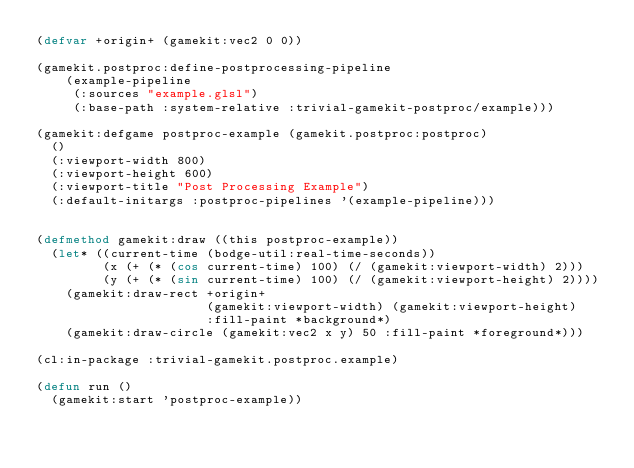<code> <loc_0><loc_0><loc_500><loc_500><_Lisp_>(defvar +origin+ (gamekit:vec2 0 0))

(gamekit.postproc:define-postprocessing-pipeline
    (example-pipeline
     (:sources "example.glsl")
     (:base-path :system-relative :trivial-gamekit-postproc/example)))

(gamekit:defgame postproc-example (gamekit.postproc:postproc)
  ()
  (:viewport-width 800)
  (:viewport-height 600)
  (:viewport-title "Post Processing Example")
  (:default-initargs :postproc-pipelines '(example-pipeline)))


(defmethod gamekit:draw ((this postproc-example))
  (let* ((current-time (bodge-util:real-time-seconds))
         (x (+ (* (cos current-time) 100) (/ (gamekit:viewport-width) 2)))
         (y (+ (* (sin current-time) 100) (/ (gamekit:viewport-height) 2))))
    (gamekit:draw-rect +origin+
                       (gamekit:viewport-width) (gamekit:viewport-height)
                       :fill-paint *background*)
    (gamekit:draw-circle (gamekit:vec2 x y) 50 :fill-paint *foreground*)))

(cl:in-package :trivial-gamekit.postproc.example)

(defun run ()
  (gamekit:start 'postproc-example))
</code> 